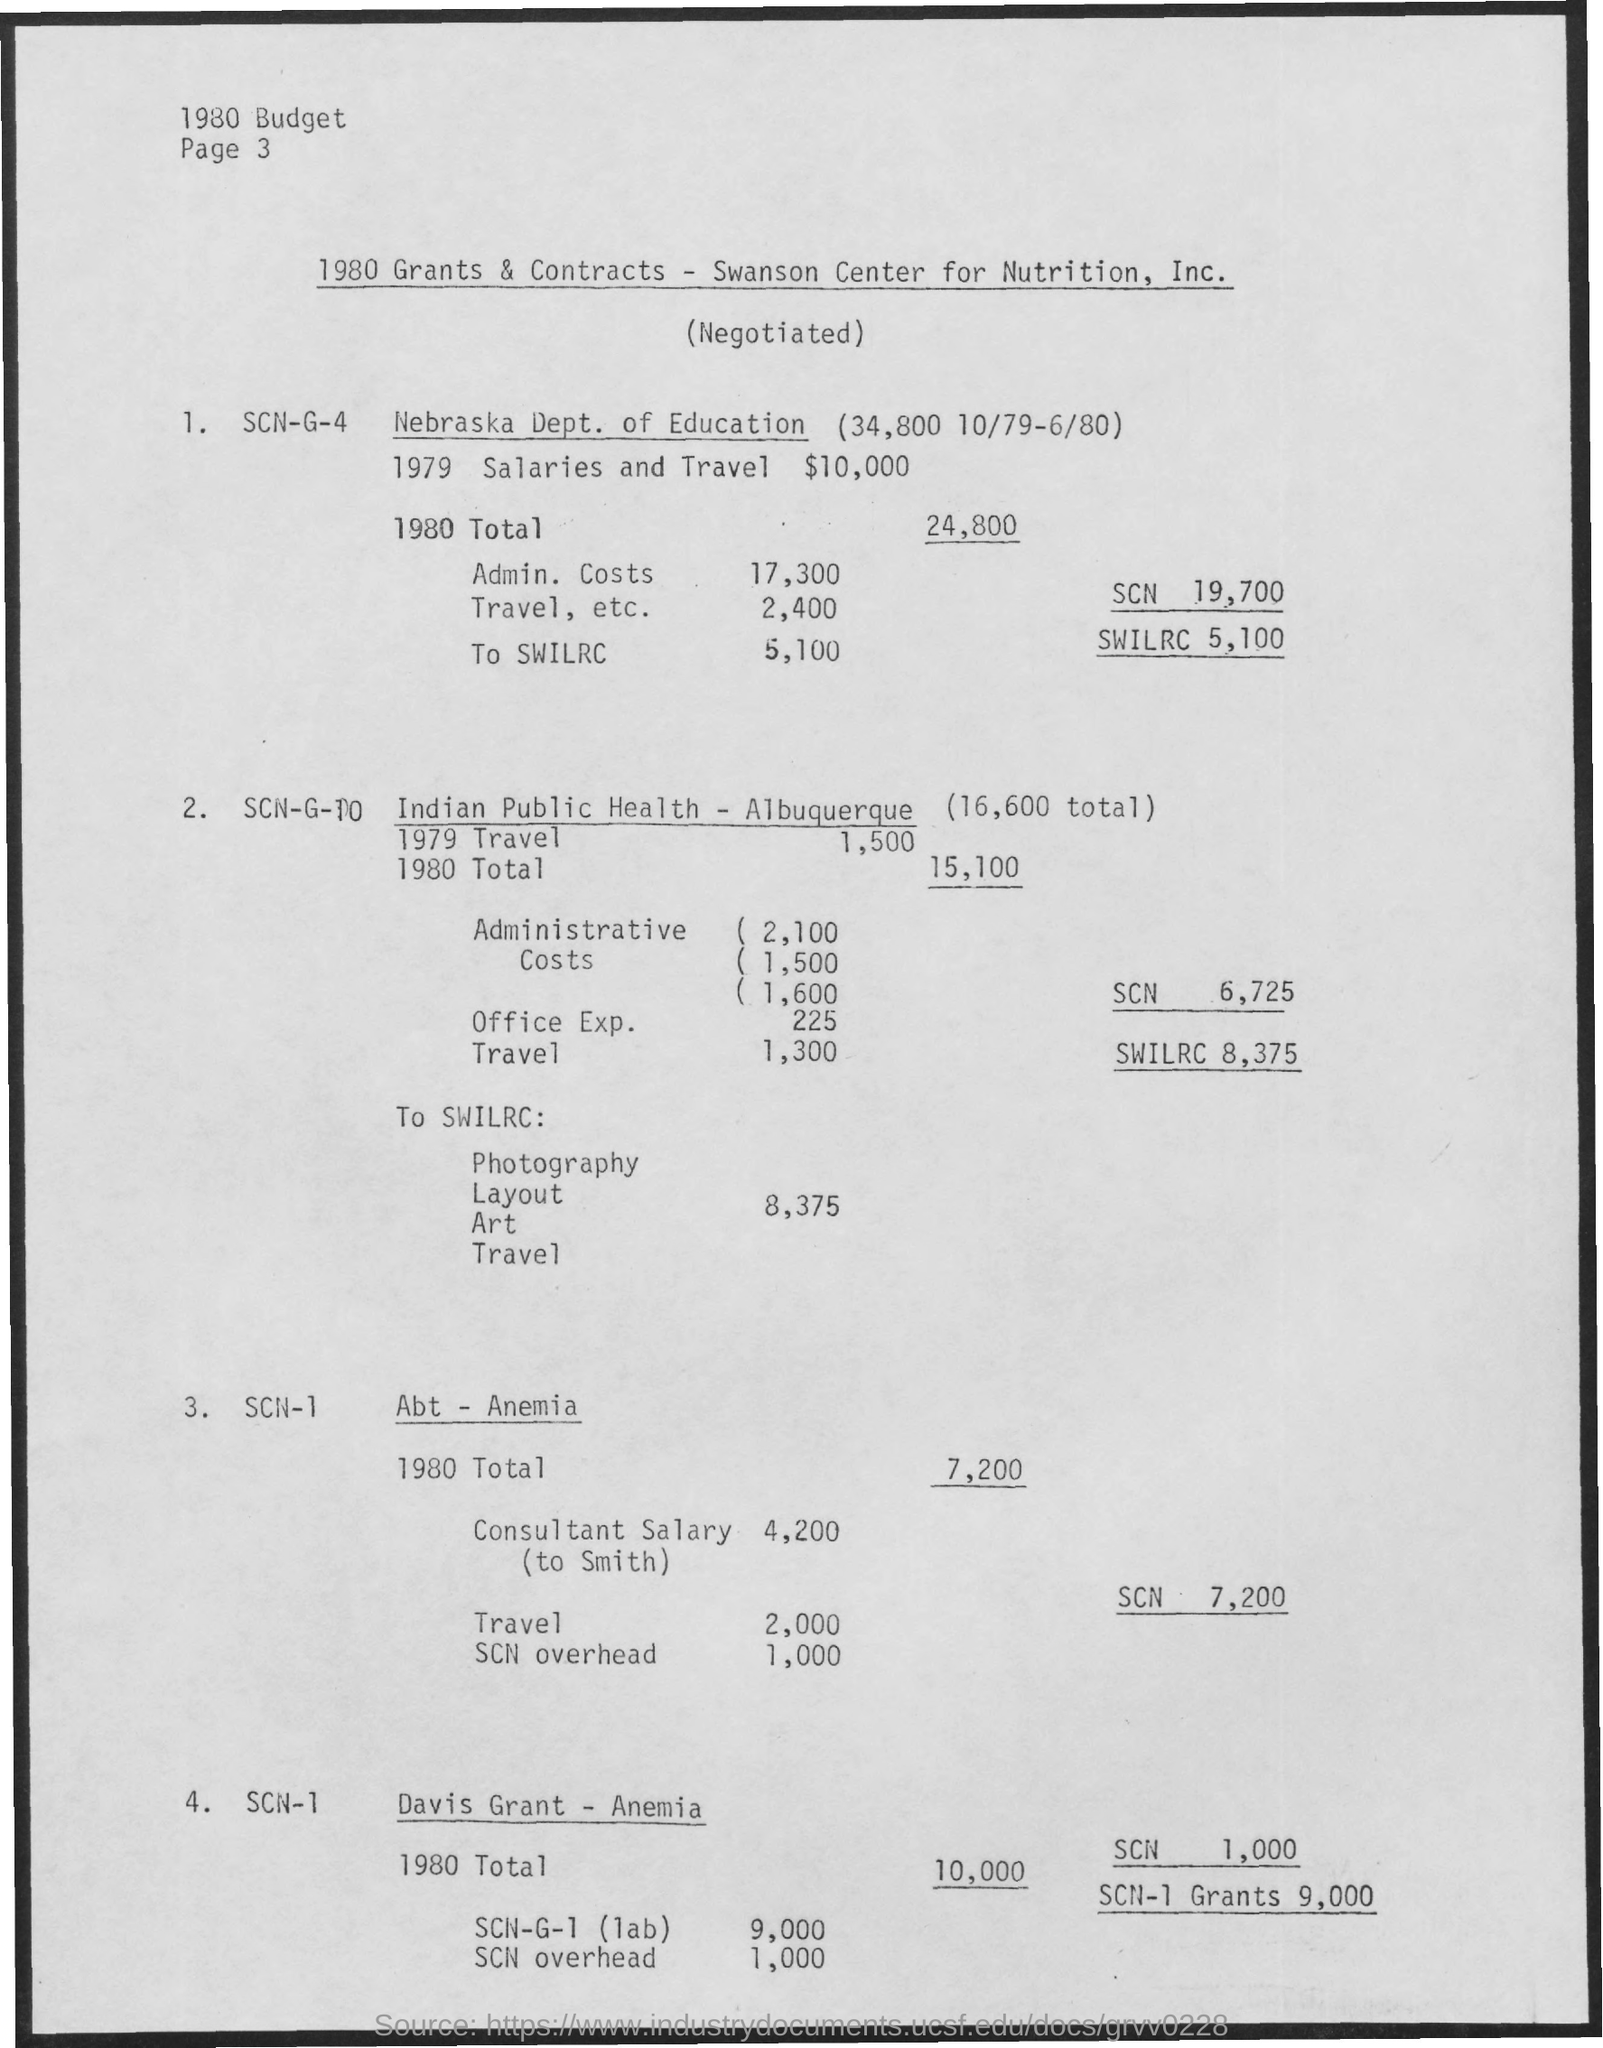What is the total budget for the Nebraska Dept. of Education for both 1979 and 1980 as per this document? According to the document, the Nebraska Dept. of Education had allocated $10,000 for 1979 and had an 1980 total (presumably including the 1979 amount carried over) of $24,800. Thus, over the two years, the total amount would be the sum of both years' figures. To clarify, the total budget allocation for the Nebraska Dept. of Education over 1979 and 1980 would be $34,800, according to the information provided in this document. 